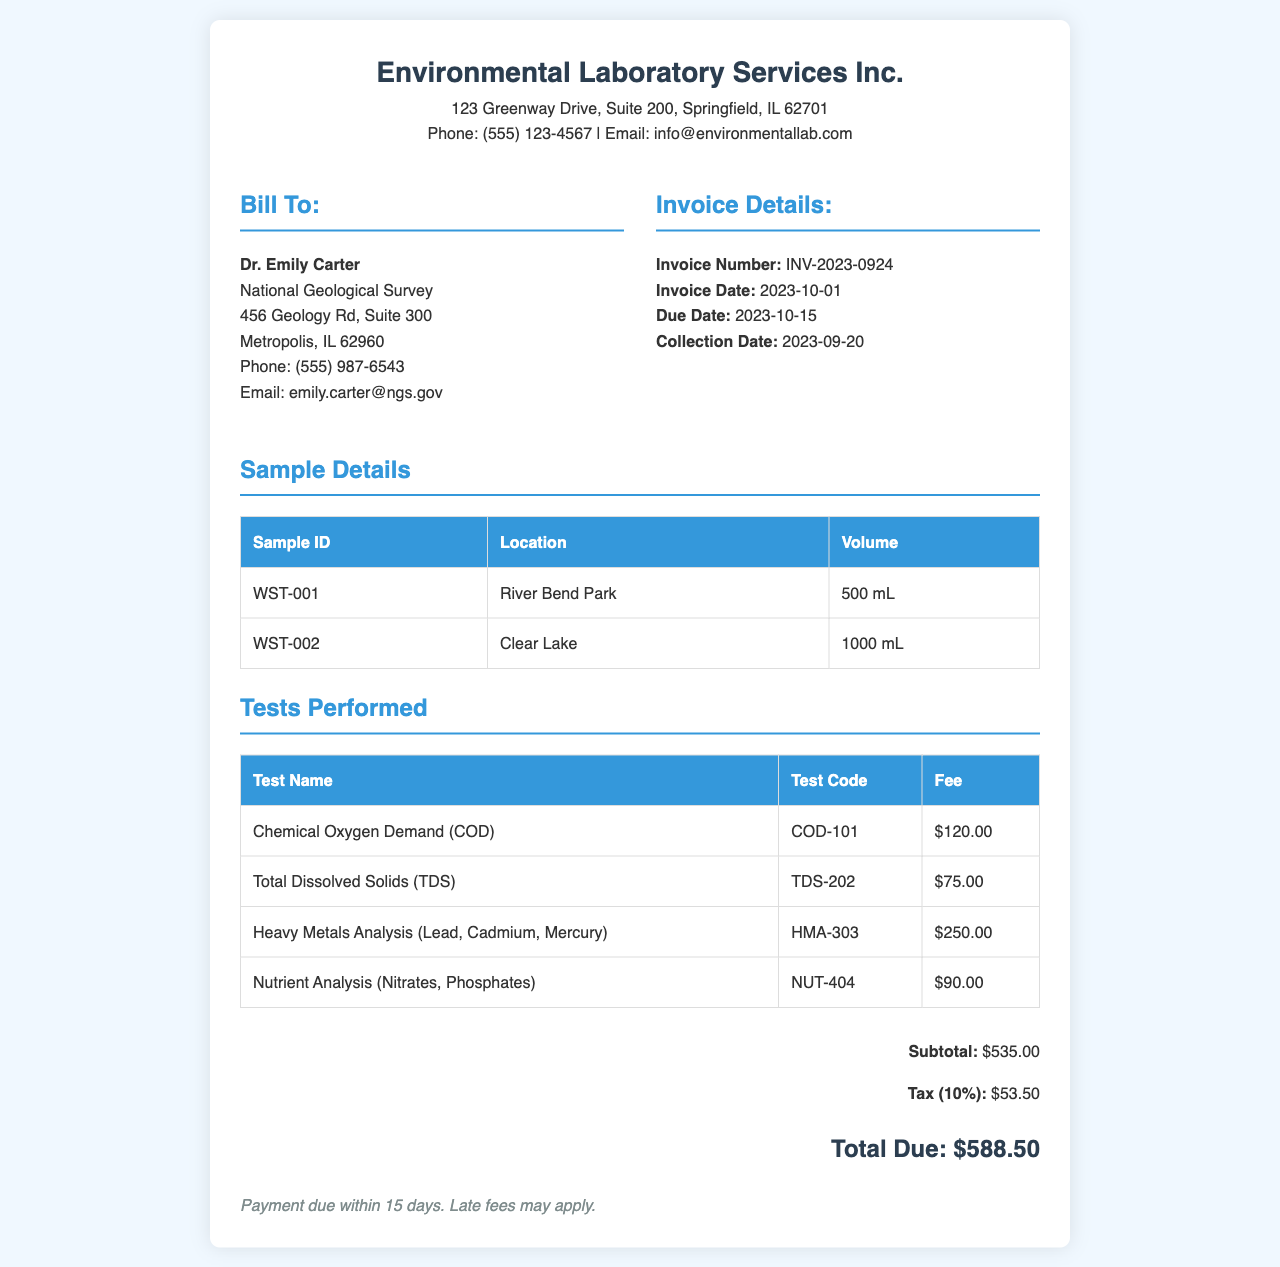What is the invoice number? The invoice number is explicitly stated in the document for reference.
Answer: INV-2023-0924 Who is the invoice billed to? The document provides the client's name and organization in the billing section.
Answer: Dr. Emily Carter What is the total due amount? The total due is calculated by adding the subtotal and tax provided in the document.
Answer: $588.50 When was the water sample collected? The collection date is specified in the invoice details.
Answer: 2023-09-20 What tests were performed for water samples? The document lists multiple analyses performed along with their corresponding test names.
Answer: Chemical Oxygen Demand (COD), Total Dissolved Solids (TDS), Heavy Metals Analysis, Nutrient Analysis What is the fee for Heavy Metals Analysis? The document provides a detailed fee structure including charges for each test.
Answer: $250.00 What is the tax percentage applied on the invoice? The tax information given specifies the tax rate used for calculations.
Answer: 10% What is the payment term stated in the document? The document mentions the payment condition for settling the invoice.
Answer: Payment due within 15 days 